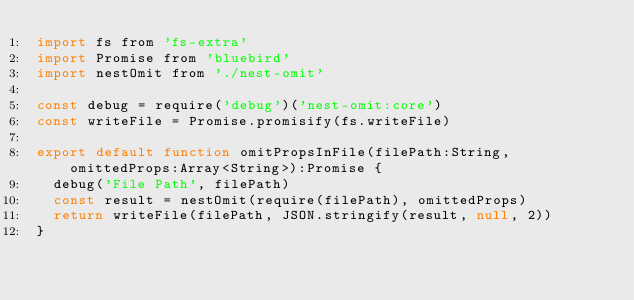<code> <loc_0><loc_0><loc_500><loc_500><_JavaScript_>import fs from 'fs-extra'
import Promise from 'bluebird'
import nestOmit from './nest-omit'

const debug = require('debug')('nest-omit:core')
const writeFile = Promise.promisify(fs.writeFile)

export default function omitPropsInFile(filePath:String, omittedProps:Array<String>):Promise {
  debug('File Path', filePath)
  const result = nestOmit(require(filePath), omittedProps)
  return writeFile(filePath, JSON.stringify(result, null, 2))
}
</code> 